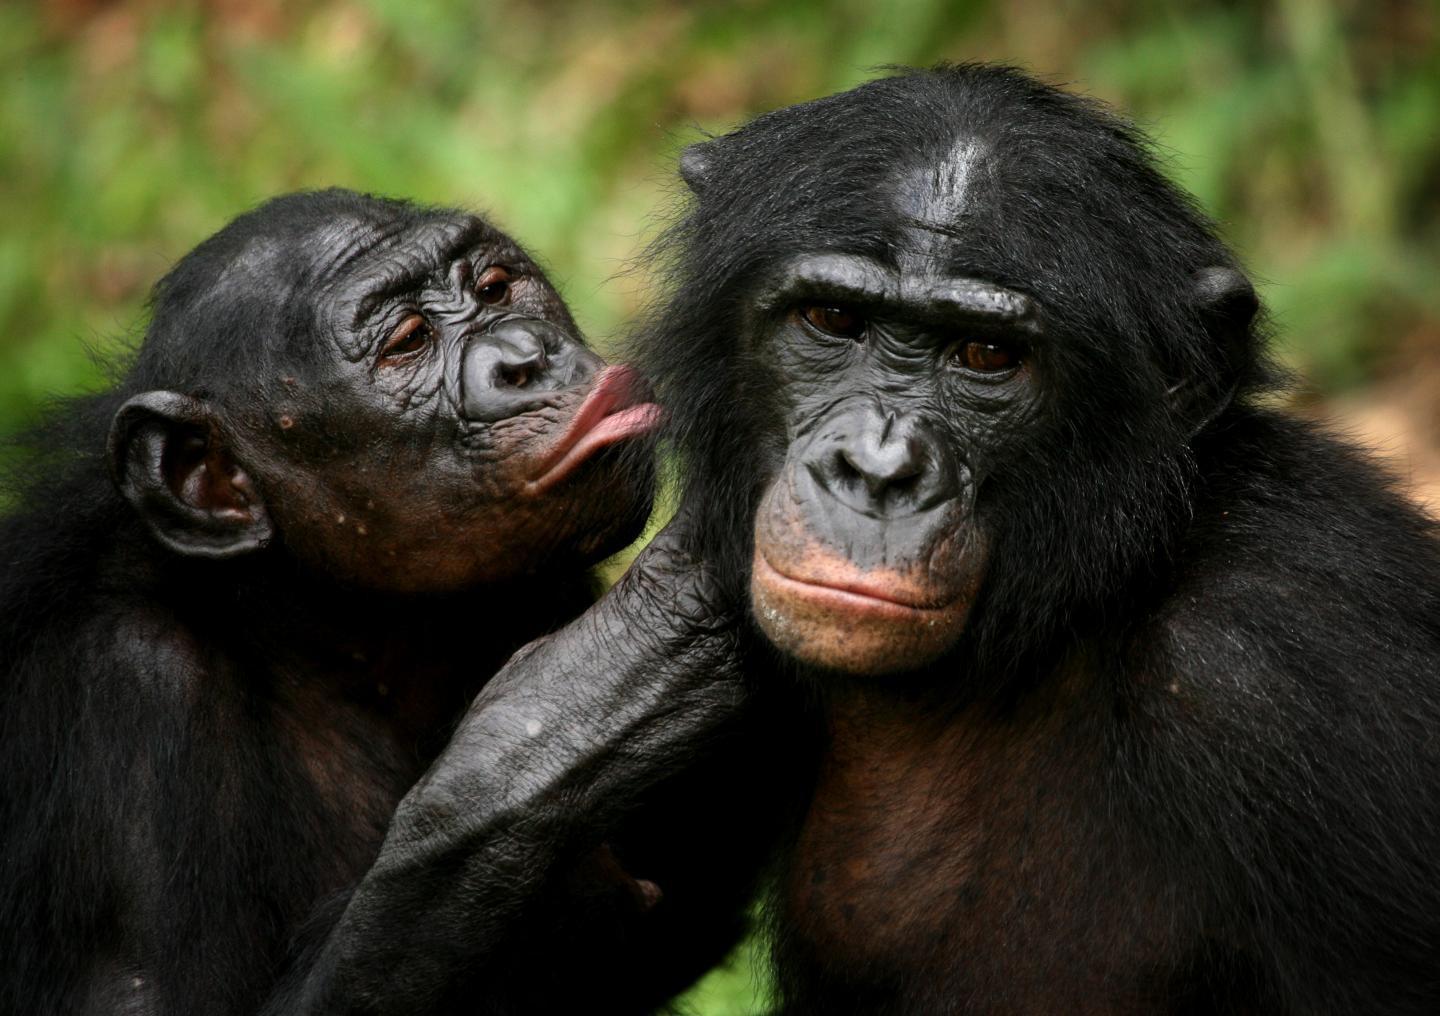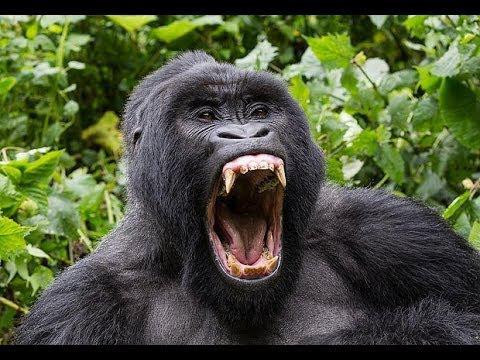The first image is the image on the left, the second image is the image on the right. Examine the images to the left and right. Is the description "One of the images depicts a gorilla grooming from behind it." accurate? Answer yes or no. No. The first image is the image on the left, the second image is the image on the right. Analyze the images presented: Is the assertion "One image shows one shaggy-haired gorilla grooming the head of a different shaggy haired gorilla, with the curled fingers of one hand facing the camera." valid? Answer yes or no. No. 